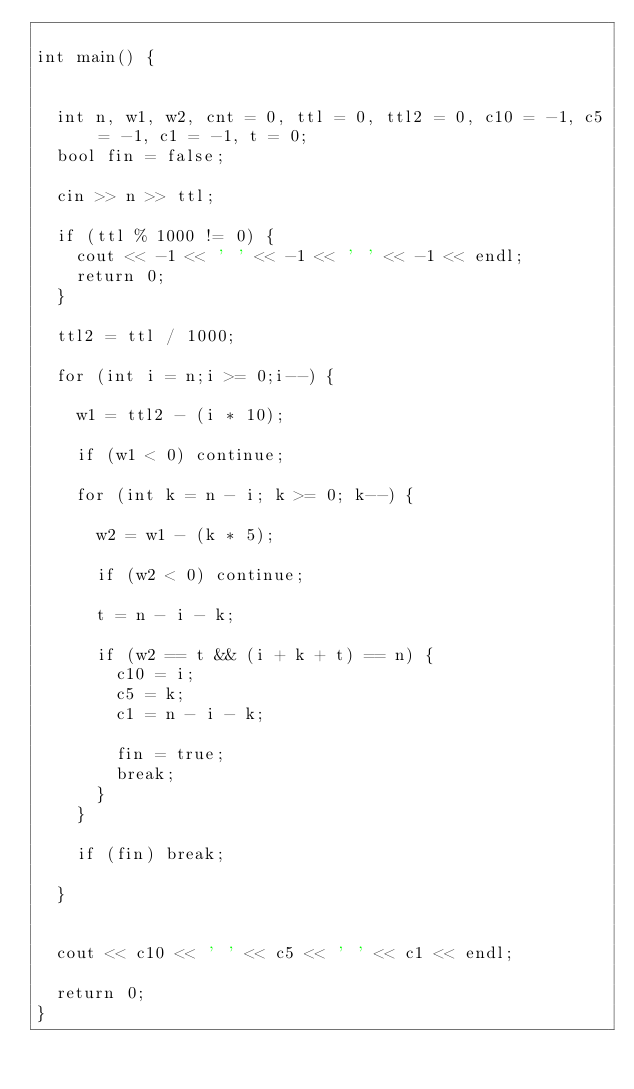Convert code to text. <code><loc_0><loc_0><loc_500><loc_500><_C++_>
int main() {


	int n, w1, w2, cnt = 0, ttl = 0, ttl2 = 0, c10 = -1, c5 = -1, c1 = -1, t = 0;
	bool fin = false;

	cin >> n >> ttl;

	if (ttl % 1000 != 0) {
		cout << -1 << ' ' << -1 << ' ' << -1 << endl;
		return 0;
	}

	ttl2 = ttl / 1000;

	for (int i = n;i >= 0;i--) {

		w1 = ttl2 - (i * 10);

		if (w1 < 0) continue;

		for (int k = n - i; k >= 0; k--) {

			w2 = w1 - (k * 5);

			if (w2 < 0) continue;

			t = n - i - k;

			if (w2 == t && (i + k + t) == n) {
				c10 = i;
				c5 = k;
				c1 = n - i - k;

				fin = true;
				break;
			}
		}

		if (fin) break;

	}


	cout << c10 << ' ' << c5 << ' ' << c1 << endl;

	return 0;
}

</code> 